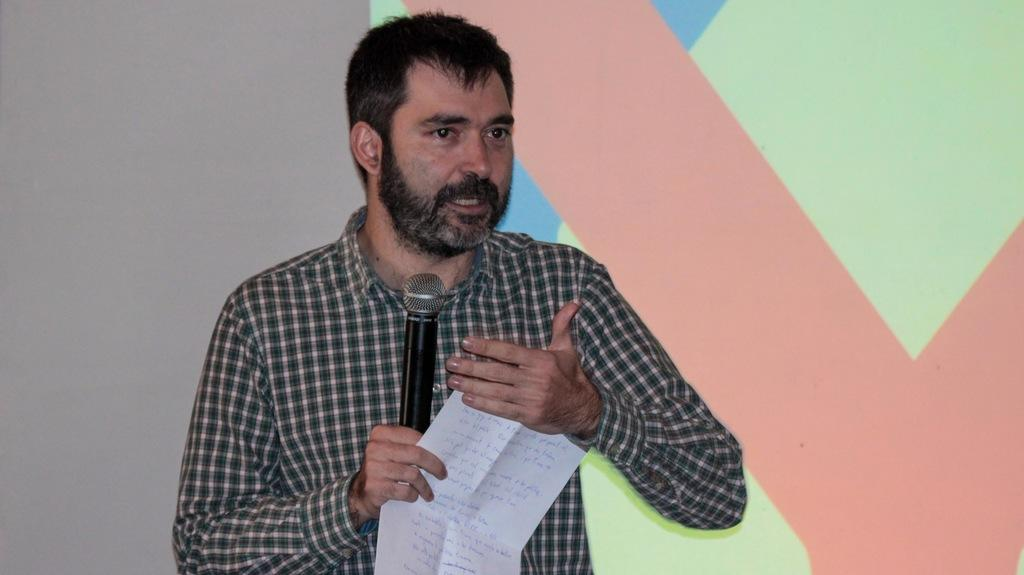Who is the main subject in the image? There is a man in the image. What is the man doing in the image? The man is standing in the image. What objects is the man holding in the image? The man is holding a microphone and a piece of paper in the image. What is the man wearing in the image? The man is wearing a shirt in the image. What level of crime is being discussed in the image? There is no indication of a crime or discussion about crime in the image. 